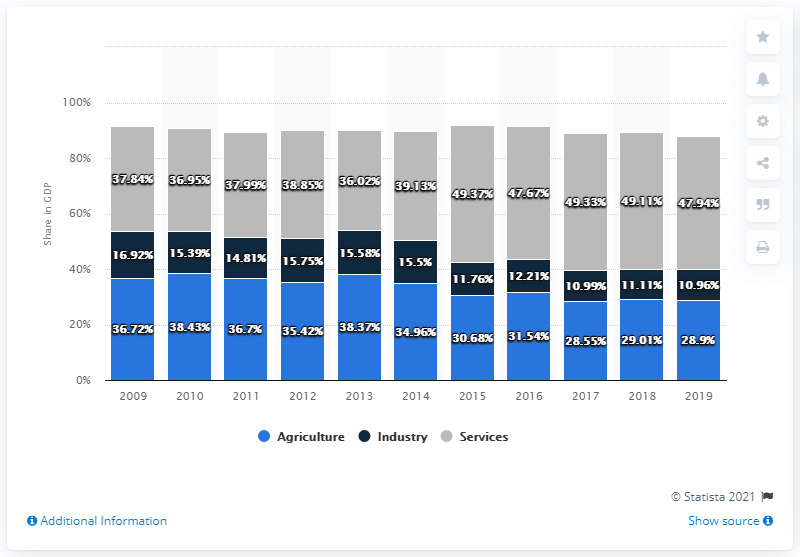Give some essential details in this illustration. In 2019, the share of agriculture in Burundi's gross domestic product was 28.9%. 